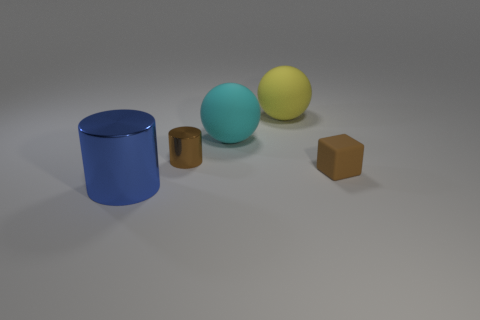Are there fewer cyan rubber spheres that are in front of the blue metallic object than big red cylinders?
Provide a succinct answer. No. How many objects are the same color as the tiny block?
Ensure brevity in your answer.  1. What is the thing that is behind the brown cylinder and on the right side of the cyan thing made of?
Offer a very short reply. Rubber. There is a small object that is to the left of the big yellow rubber thing; is it the same color as the tiny thing in front of the brown cylinder?
Give a very brief answer. Yes. What number of gray objects are metallic cylinders or matte balls?
Your answer should be very brief. 0. Is the number of yellow objects that are in front of the cyan rubber sphere less than the number of big cyan matte balls to the right of the yellow matte object?
Offer a terse response. No. Is there a yellow rubber thing that has the same size as the brown metal thing?
Your answer should be very brief. No. Do the brown object in front of the brown metallic object and the brown cylinder have the same size?
Provide a succinct answer. Yes. Is the number of small brown shiny cylinders greater than the number of small purple cubes?
Make the answer very short. Yes. Is there a tiny purple rubber object of the same shape as the large blue thing?
Provide a succinct answer. No. 